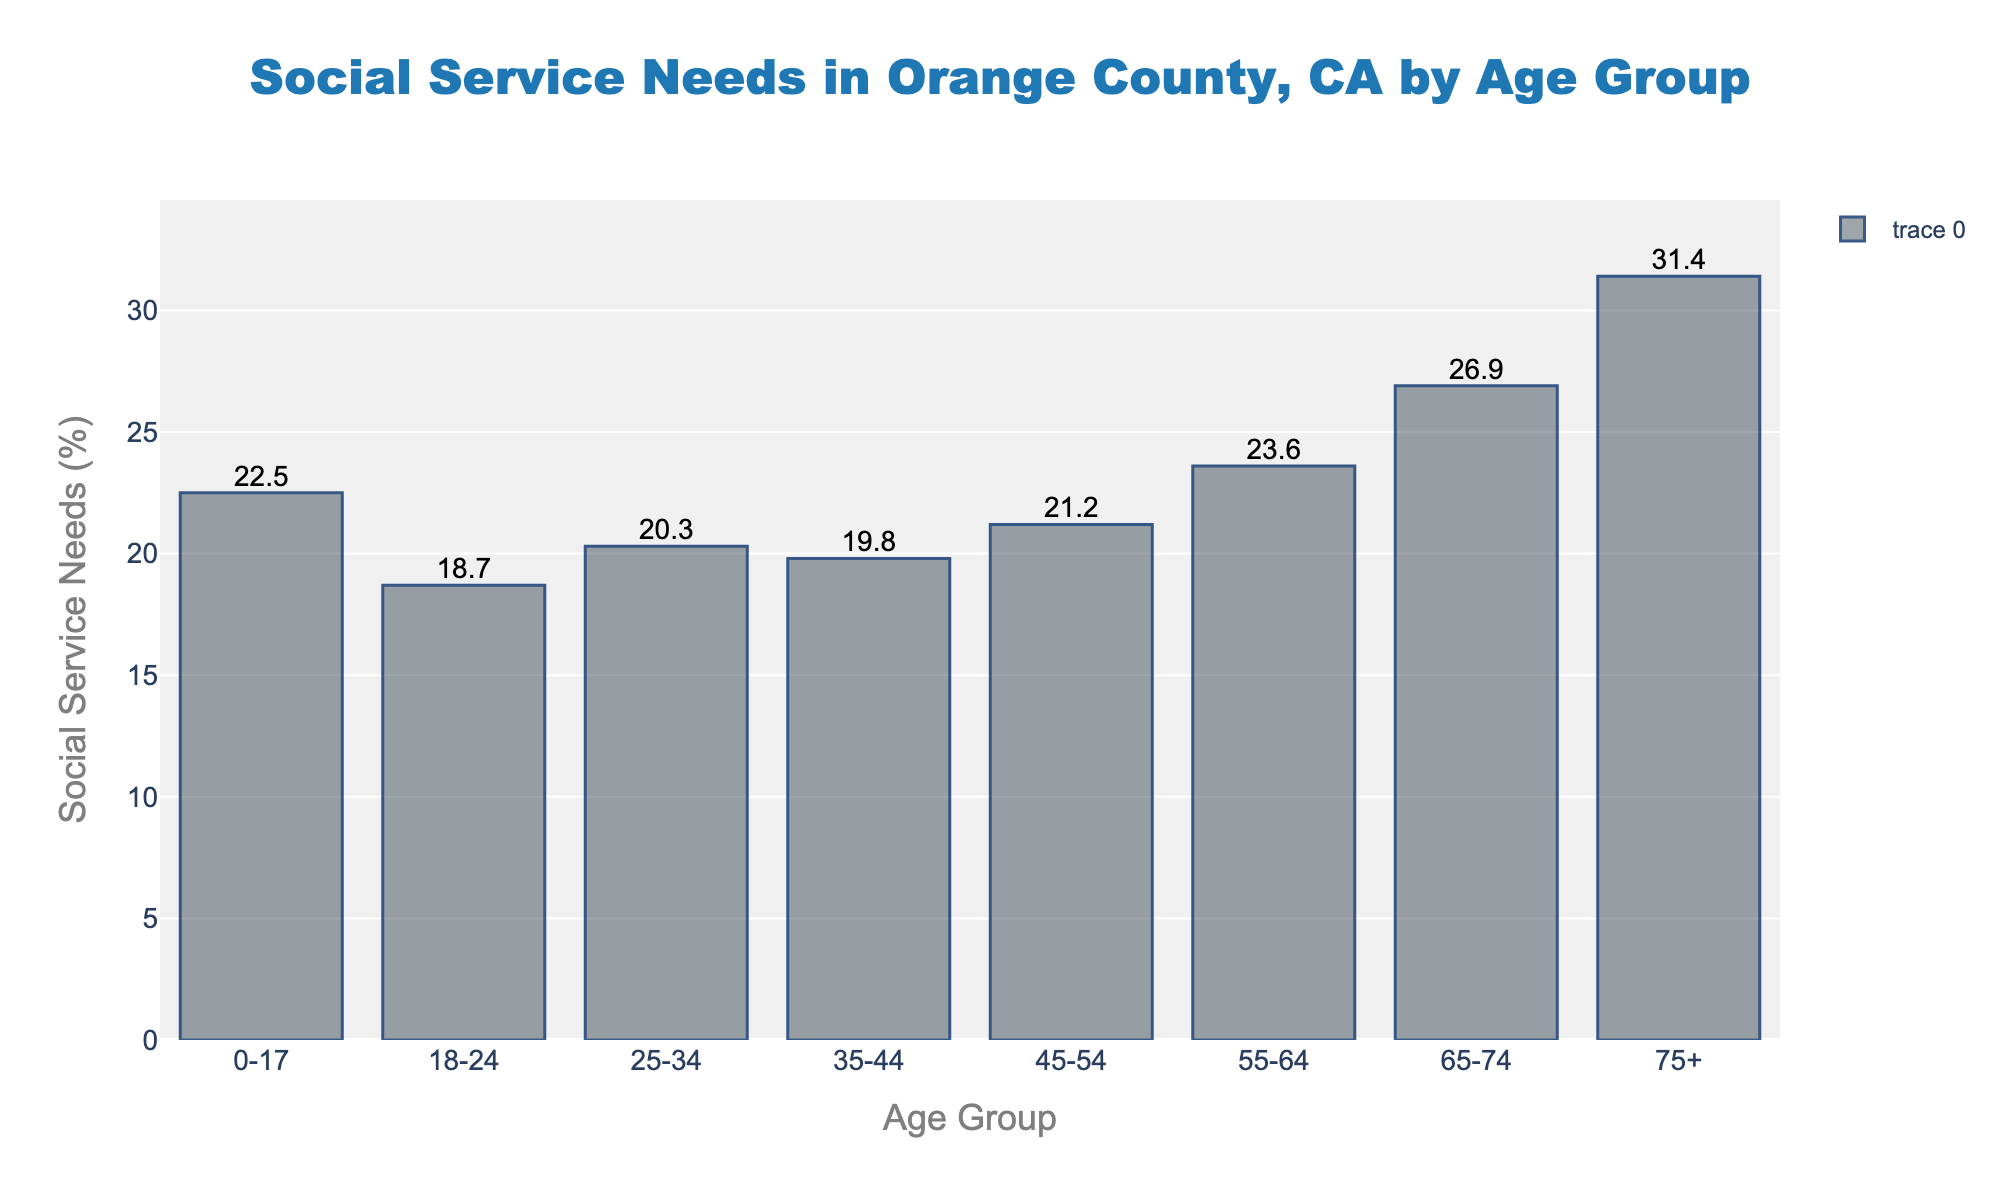What is the percentage of social service needs for the 75+ age group? Look at the bar for the age group "75+" and read the value of the percentage label on top of it. It shows 31.4%.
Answer: 31.4% Which age group has the highest social service needs? Compare all the bars' heights or the percentage labels on top. The tallest bar is for the age group "75+", with a percentage of 31.4%.
Answer: 75+ What is the difference in social service needs between the 0-17 and 65-74 age groups? Subtract the percentage of the 0-17 age group (22.5%) from the 65-74 age group (26.9%). The difference is 26.9% - 22.5% = 4.4%.
Answer: 4.4% What is the average percentage of social service needs for the age groups 25-34, 35-44, and 45-54? Add the percentages of these age groups and divide by 3. (20.3% + 19.8% + 21.2%) / 3 = 20.433%.
Answer: 20.433% Which two consecutive age groups have the smallest difference in social service needs? Calculate the differences between consecutive age groups and find the smallest. The smallest difference is between the 35-44 and 45-54 age groups: 21.2% - 19.8% = 1.4%.
Answer: 35-44 and 45-54 Is the percentage of social service needs for the 55-64 age group higher than the 18-24 age group? Compare the percentages of the 55-64 age group (23.6%) and the 18-24 age group (18.7%). Since 23.6% is greater than 18.7%, the answer is yes.
Answer: Yes Which age group has the lowest social service needs percentage? Identify the shortest bar or the smallest value in the percentage labels. The age group 18-24 has the lowest percentage at 18.7%.
Answer: 18-24 What is the total percentage of social service needs for all age groups combined? Sum all the percentages: 22.5% + 18.7% + 20.3% + 19.8% + 21.2% + 23.6% + 26.9% + 31.4% = 184.4%.
Answer: 184.4% How many age groups have a social service needs percentage greater than 20%? Count the age groups with a percentage above 20%. They are 0-17, 25-34, 45-54, 55-64, 65-74, and 75+, totaling 6 age groups.
Answer: 6 